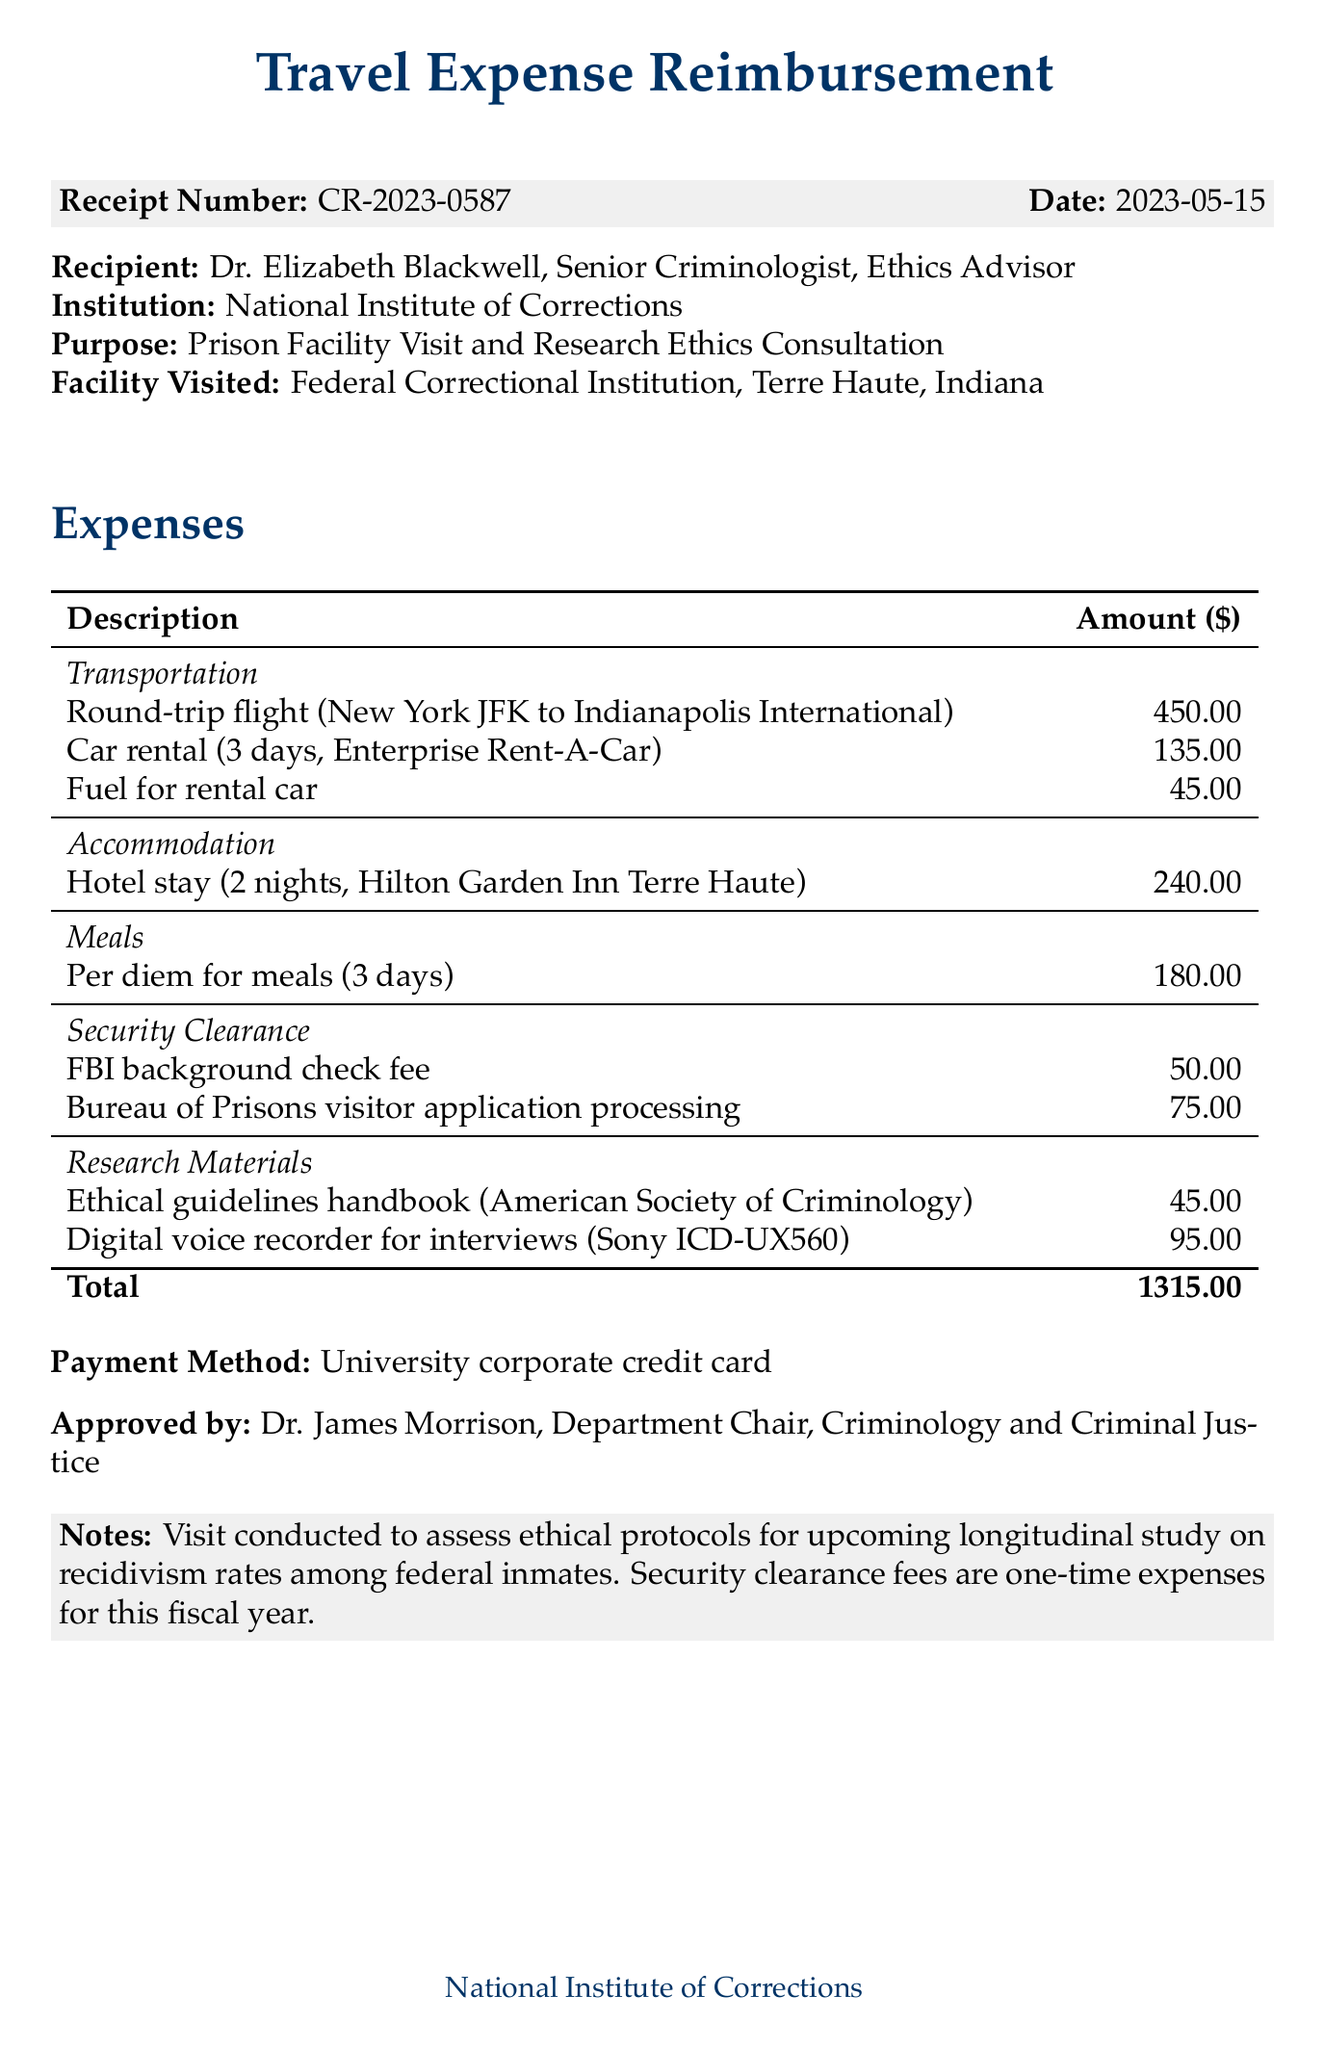What is the receipt number? The receipt number is provided at the top of the document, typically for tracking purposes.
Answer: CR-2023-0587 Who is the recipient of the reimbursement? The document lists the name of the person receiving the reimbursement, which is important for record-keeping.
Answer: Dr. Elizabeth Blackwell What is the total amount of expenses? The total amount is calculated from the sum of all categories of expenses included in the document.
Answer: 1315.00 What facility was visited? The document specifies the name of the facility that was visited during the trip, indicating the venue for the research activity.
Answer: Federal Correctional Institution, Terre Haute What fees are included under security clearance? The document lists specific fees associated with security clearance, which are important for understanding total costs.
Answer: FBI background check fee, Bureau of Prisons visitor application processing What was the purpose of the visit? The purpose is stated in the document and reflects the reason for incurring the expenses.
Answer: Prison Facility Visit and Research Ethics Consultation How many nights was the hotel stay? The accommodation section specifies the duration of the hotel stay, which helps in assessing lodging expenses.
Answer: 2 nights What method was used for payment? The method of payment is indicated in the document, which is relevant for financial tracking.
Answer: University corporate credit card 